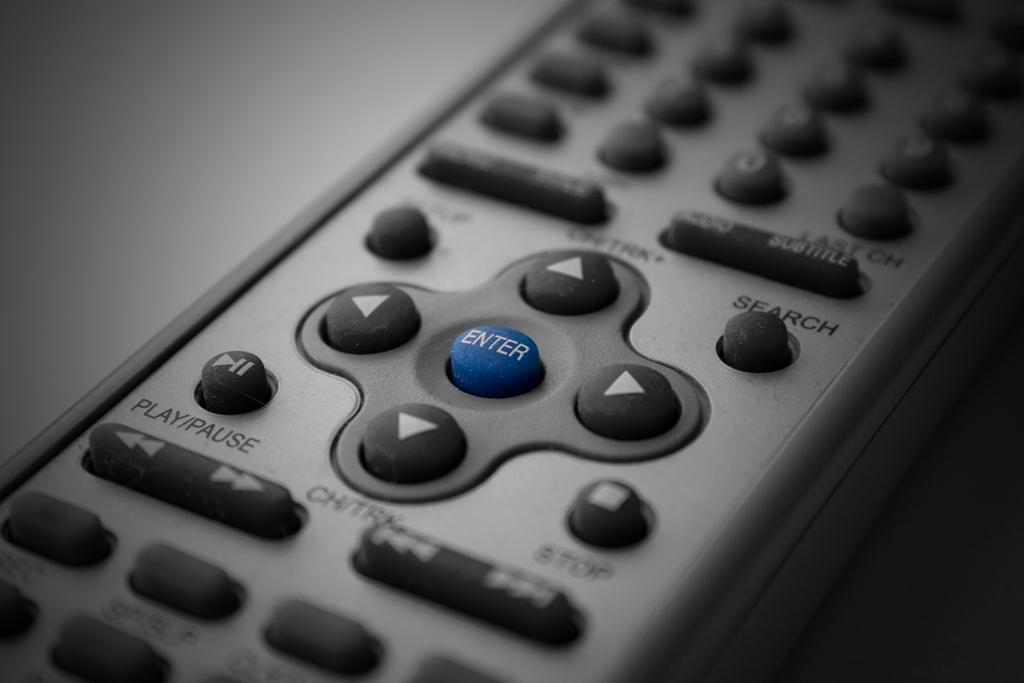<image>
Offer a succinct explanation of the picture presented. A gray remote with a blue enter button in the center of four directional buttons. 